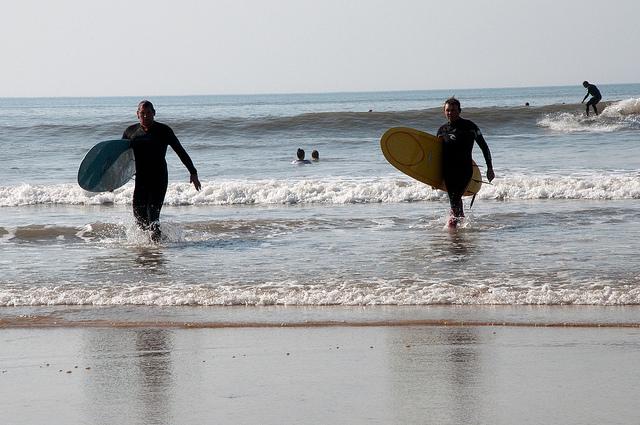What's the weather like?
Short answer required. Sunny. What sport are they doing?
Short answer required. Surfing. How many people are in the water?
Keep it brief. 7. 